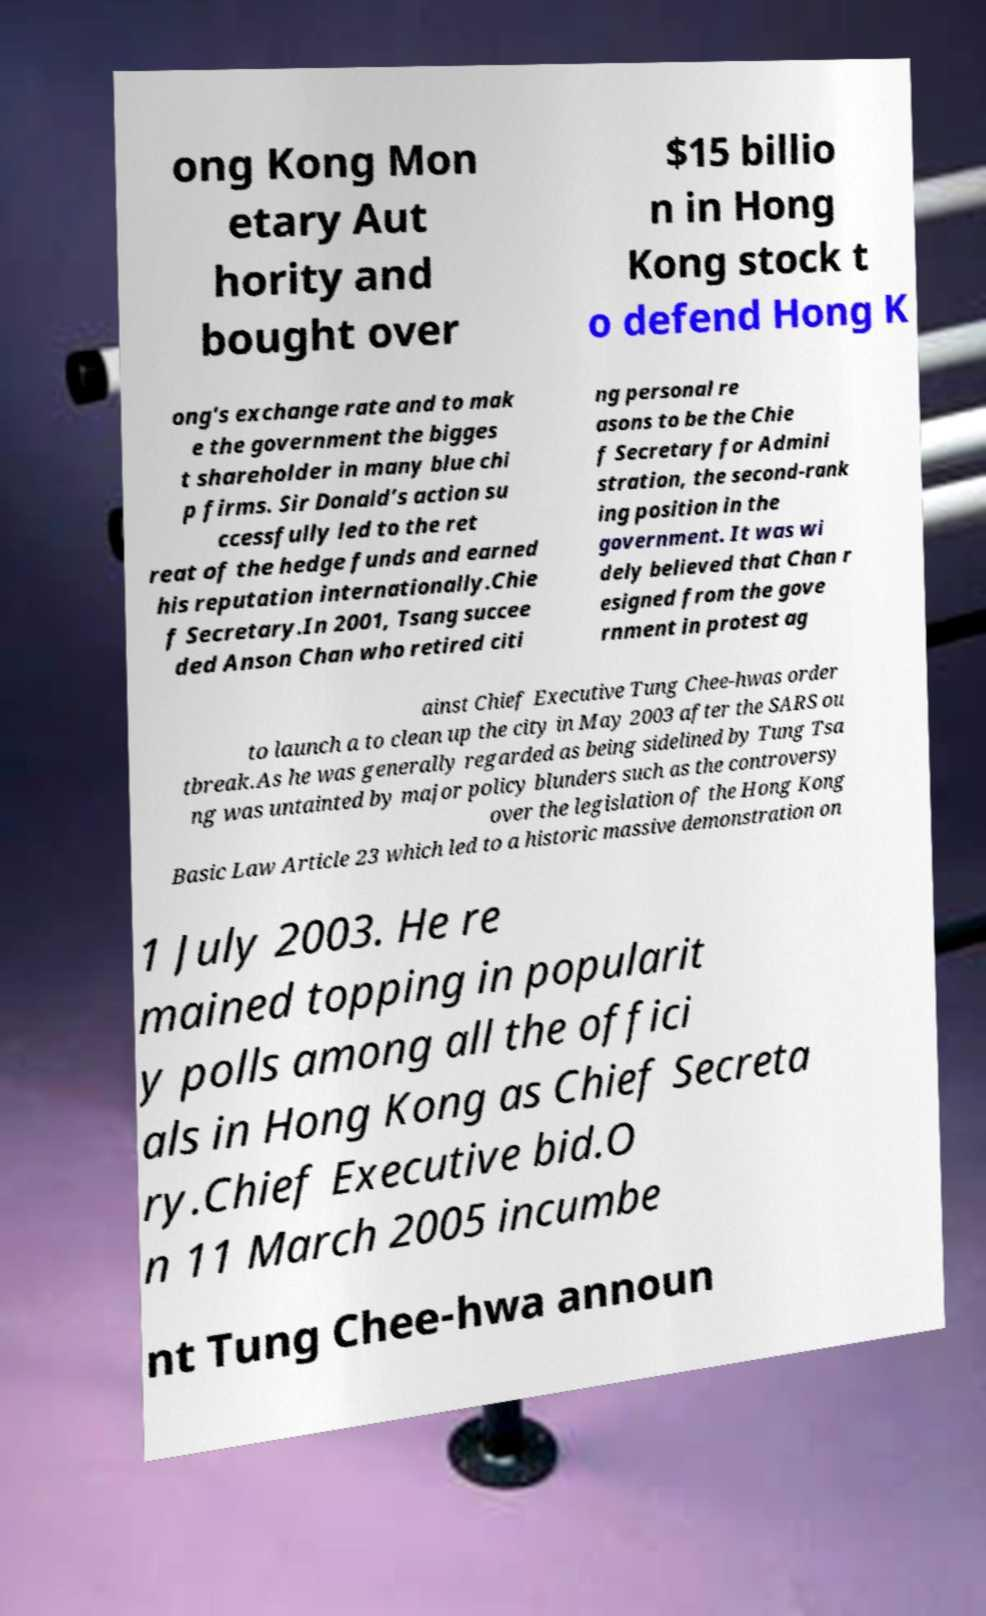Please read and relay the text visible in this image. What does it say? ong Kong Mon etary Aut hority and bought over $15 billio n in Hong Kong stock t o defend Hong K ong's exchange rate and to mak e the government the bigges t shareholder in many blue chi p firms. Sir Donald’s action su ccessfully led to the ret reat of the hedge funds and earned his reputation internationally.Chie f Secretary.In 2001, Tsang succee ded Anson Chan who retired citi ng personal re asons to be the Chie f Secretary for Admini stration, the second-rank ing position in the government. It was wi dely believed that Chan r esigned from the gove rnment in protest ag ainst Chief Executive Tung Chee-hwas order to launch a to clean up the city in May 2003 after the SARS ou tbreak.As he was generally regarded as being sidelined by Tung Tsa ng was untainted by major policy blunders such as the controversy over the legislation of the Hong Kong Basic Law Article 23 which led to a historic massive demonstration on 1 July 2003. He re mained topping in popularit y polls among all the offici als in Hong Kong as Chief Secreta ry.Chief Executive bid.O n 11 March 2005 incumbe nt Tung Chee-hwa announ 